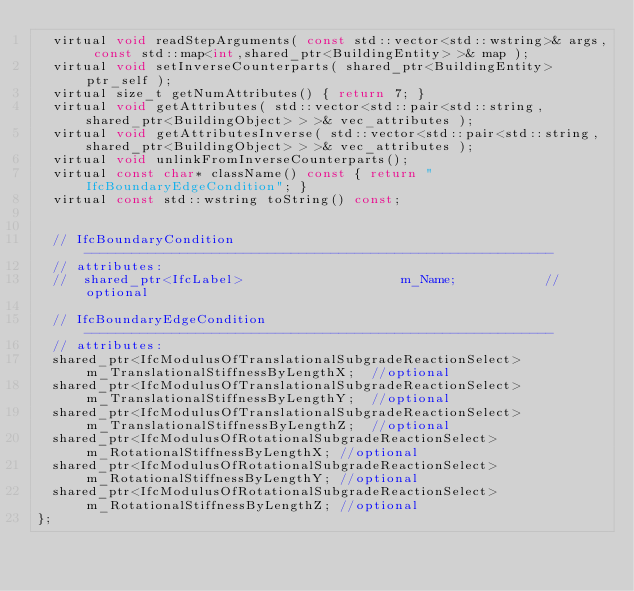Convert code to text. <code><loc_0><loc_0><loc_500><loc_500><_C_>	virtual void readStepArguments( const std::vector<std::wstring>& args, const std::map<int,shared_ptr<BuildingEntity> >& map );
	virtual void setInverseCounterparts( shared_ptr<BuildingEntity> ptr_self );
	virtual size_t getNumAttributes() { return 7; }
	virtual void getAttributes( std::vector<std::pair<std::string, shared_ptr<BuildingObject> > >& vec_attributes );
	virtual void getAttributesInverse( std::vector<std::pair<std::string, shared_ptr<BuildingObject> > >& vec_attributes );
	virtual void unlinkFromInverseCounterparts();
	virtual const char* className() const { return "IfcBoundaryEdgeCondition"; }
	virtual const std::wstring toString() const;


	// IfcBoundaryCondition -----------------------------------------------------------
	// attributes:
	//  shared_ptr<IfcLabel>										m_Name;						//optional

	// IfcBoundaryEdgeCondition -----------------------------------------------------------
	// attributes:
	shared_ptr<IfcModulusOfTranslationalSubgradeReactionSelect>	m_TranslationalStiffnessByLengthX;	//optional
	shared_ptr<IfcModulusOfTranslationalSubgradeReactionSelect>	m_TranslationalStiffnessByLengthY;	//optional
	shared_ptr<IfcModulusOfTranslationalSubgradeReactionSelect>	m_TranslationalStiffnessByLengthZ;	//optional
	shared_ptr<IfcModulusOfRotationalSubgradeReactionSelect>	m_RotationalStiffnessByLengthX;	//optional
	shared_ptr<IfcModulusOfRotationalSubgradeReactionSelect>	m_RotationalStiffnessByLengthY;	//optional
	shared_ptr<IfcModulusOfRotationalSubgradeReactionSelect>	m_RotationalStiffnessByLengthZ;	//optional
};

</code> 